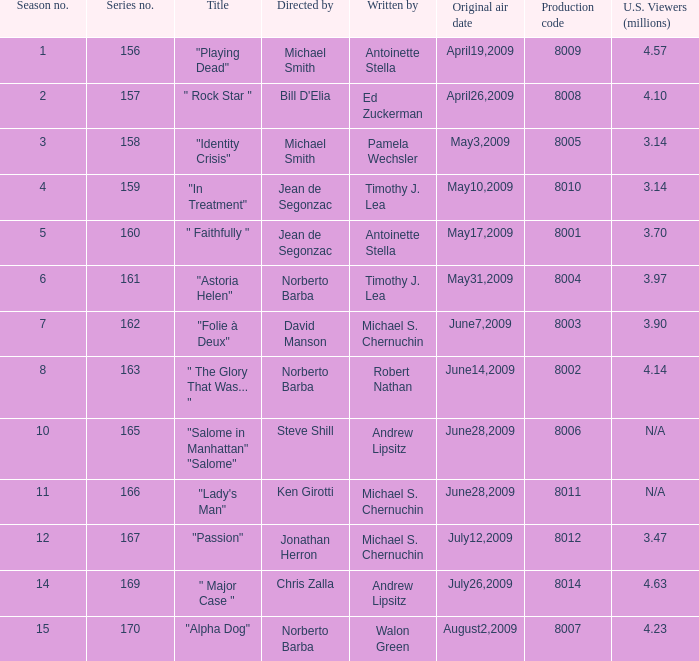Could you parse the entire table as a dict? {'header': ['Season no.', 'Series no.', 'Title', 'Directed by', 'Written by', 'Original air date', 'Production code', 'U.S. Viewers (millions)'], 'rows': [['1', '156', '"Playing Dead"', 'Michael Smith', 'Antoinette Stella', 'April19,2009', '8009', '4.57'], ['2', '157', '" Rock Star "', "Bill D'Elia", 'Ed Zuckerman', 'April26,2009', '8008', '4.10'], ['3', '158', '"Identity Crisis"', 'Michael Smith', 'Pamela Wechsler', 'May3,2009', '8005', '3.14'], ['4', '159', '"In Treatment"', 'Jean de Segonzac', 'Timothy J. Lea', 'May10,2009', '8010', '3.14'], ['5', '160', '" Faithfully "', 'Jean de Segonzac', 'Antoinette Stella', 'May17,2009', '8001', '3.70'], ['6', '161', '"Astoria Helen"', 'Norberto Barba', 'Timothy J. Lea', 'May31,2009', '8004', '3.97'], ['7', '162', '"Folie à Deux"', 'David Manson', 'Michael S. Chernuchin', 'June7,2009', '8003', '3.90'], ['8', '163', '" The Glory That Was... "', 'Norberto Barba', 'Robert Nathan', 'June14,2009', '8002', '4.14'], ['10', '165', '"Salome in Manhattan" "Salome"', 'Steve Shill', 'Andrew Lipsitz', 'June28,2009', '8006', 'N/A'], ['11', '166', '"Lady\'s Man"', 'Ken Girotti', 'Michael S. Chernuchin', 'June28,2009', '8011', 'N/A'], ['12', '167', '"Passion"', 'Jonathan Herron', 'Michael S. Chernuchin', 'July12,2009', '8012', '3.47'], ['14', '169', '" Major Case "', 'Chris Zalla', 'Andrew Lipsitz', 'July26,2009', '8014', '4.63'], ['15', '170', '"Alpha Dog"', 'Norberto Barba', 'Walon Green', 'August2,2009', '8007', '4.23']]} How many writers write the episode whose director is Jonathan Herron? 1.0. 